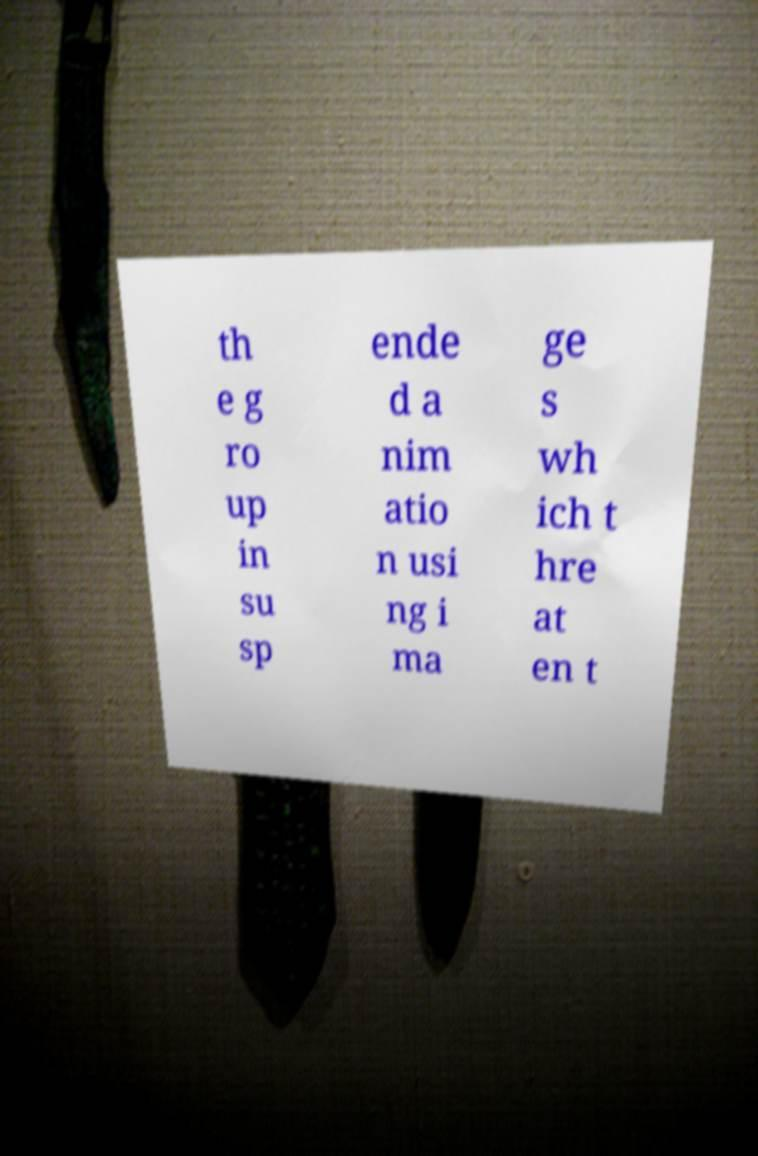For documentation purposes, I need the text within this image transcribed. Could you provide that? th e g ro up in su sp ende d a nim atio n usi ng i ma ge s wh ich t hre at en t 